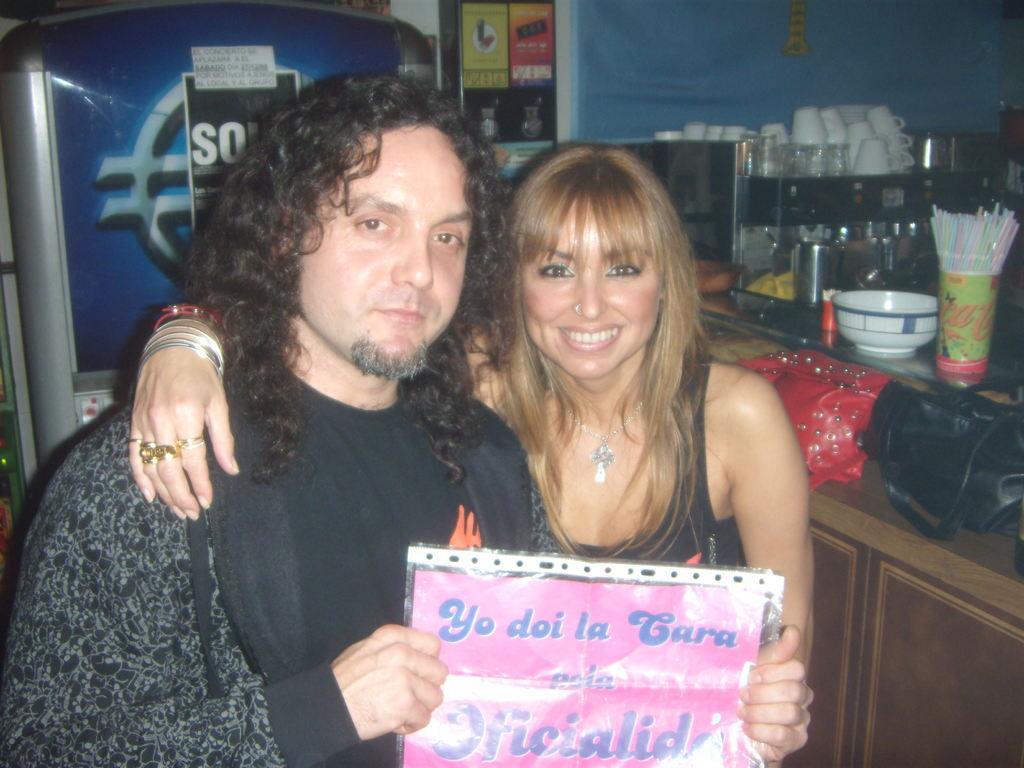In one or two sentences, can you explain what this image depicts? In this image there is a man and a woman holding a poster in there hands, on that there is some text in the background there is a table on that table there is a bowl, straws and cups and a fridge. 